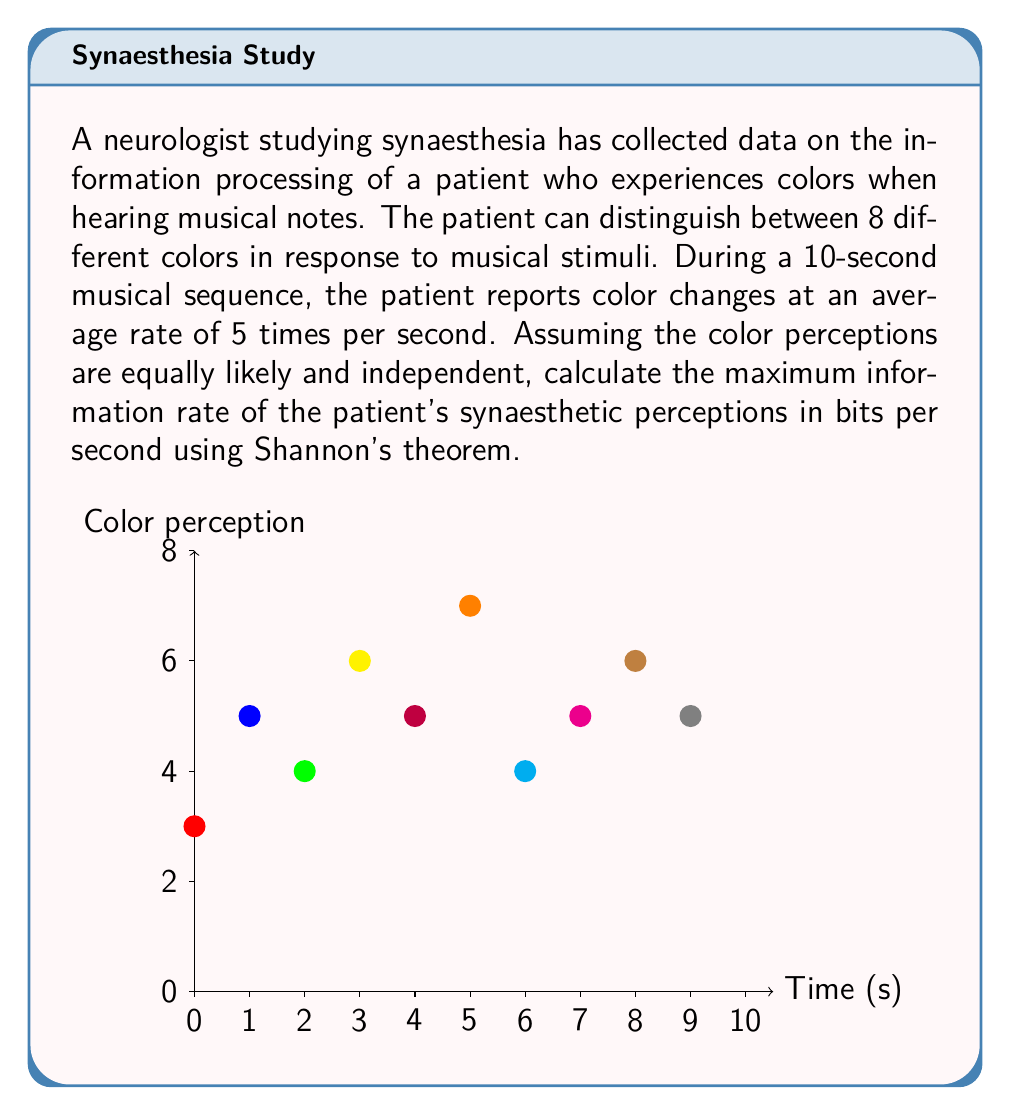Solve this math problem. To solve this problem, we'll use Shannon's theorem and follow these steps:

1) First, recall Shannon's theorem for information rate:
   $$R = H \cdot f$$
   where $R$ is the information rate, $H$ is the entropy per symbol, and $f$ is the symbol rate.

2) Calculate the entropy per symbol ($H$):
   For 8 equally likely colors, the entropy is:
   $$H = -\sum_{i=1}^{8} p_i \log_2(p_i) = -8 \cdot \frac{1}{8} \log_2(\frac{1}{8}) = \log_2(8) = 3 \text{ bits}$$

3) Determine the symbol rate ($f$):
   The patient reports color changes 5 times per second on average.
   $$f = 5 \text{ symbols/second}$$

4) Apply Shannon's theorem:
   $$R = H \cdot f = 3 \text{ bits} \cdot 5 \text{ symbols/second} = 15 \text{ bits/second}$$

Therefore, the maximum information rate of the patient's synaesthetic perceptions is 15 bits per second.
Answer: 15 bits/second 